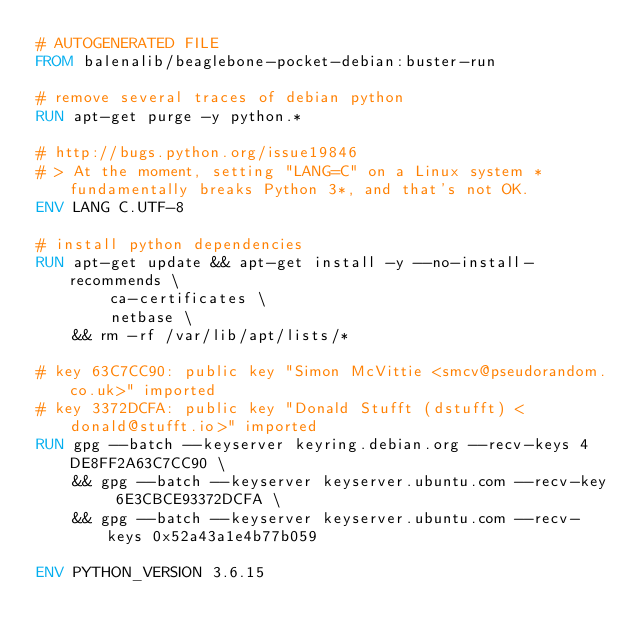Convert code to text. <code><loc_0><loc_0><loc_500><loc_500><_Dockerfile_># AUTOGENERATED FILE
FROM balenalib/beaglebone-pocket-debian:buster-run

# remove several traces of debian python
RUN apt-get purge -y python.*

# http://bugs.python.org/issue19846
# > At the moment, setting "LANG=C" on a Linux system *fundamentally breaks Python 3*, and that's not OK.
ENV LANG C.UTF-8

# install python dependencies
RUN apt-get update && apt-get install -y --no-install-recommends \
		ca-certificates \
		netbase \
	&& rm -rf /var/lib/apt/lists/*

# key 63C7CC90: public key "Simon McVittie <smcv@pseudorandom.co.uk>" imported
# key 3372DCFA: public key "Donald Stufft (dstufft) <donald@stufft.io>" imported
RUN gpg --batch --keyserver keyring.debian.org --recv-keys 4DE8FF2A63C7CC90 \
	&& gpg --batch --keyserver keyserver.ubuntu.com --recv-key 6E3CBCE93372DCFA \
	&& gpg --batch --keyserver keyserver.ubuntu.com --recv-keys 0x52a43a1e4b77b059

ENV PYTHON_VERSION 3.6.15
</code> 